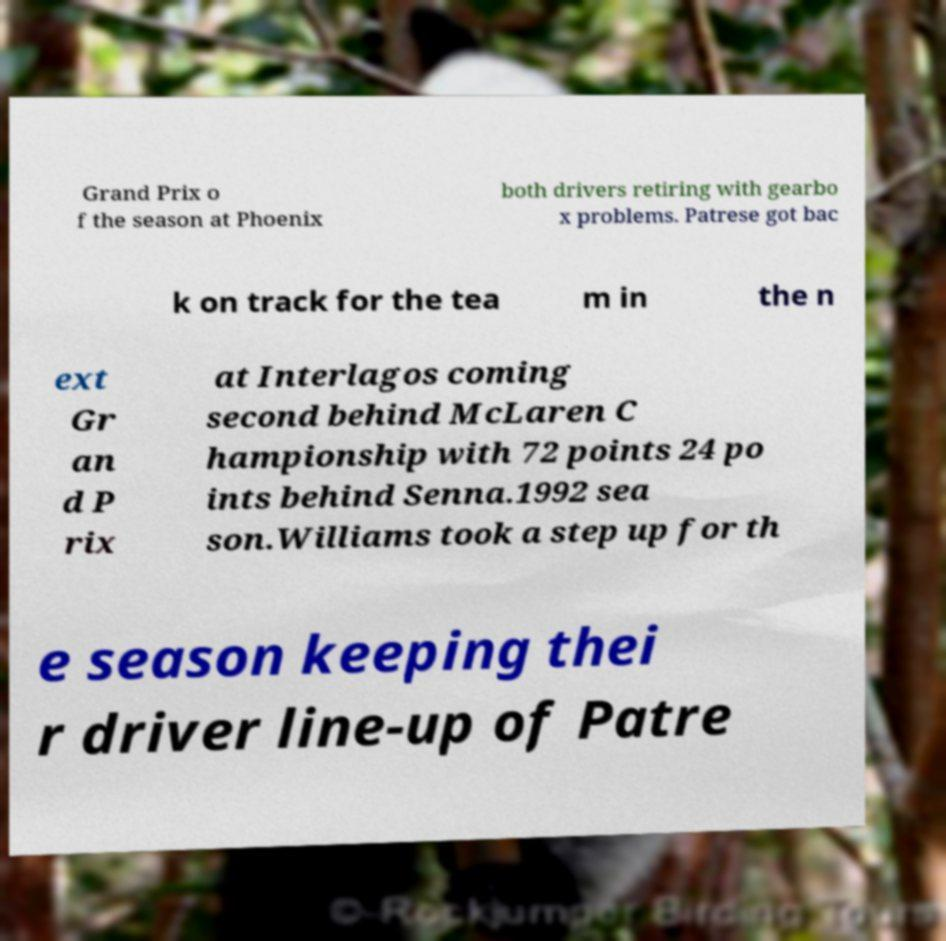Can you accurately transcribe the text from the provided image for me? Grand Prix o f the season at Phoenix both drivers retiring with gearbo x problems. Patrese got bac k on track for the tea m in the n ext Gr an d P rix at Interlagos coming second behind McLaren C hampionship with 72 points 24 po ints behind Senna.1992 sea son.Williams took a step up for th e season keeping thei r driver line-up of Patre 